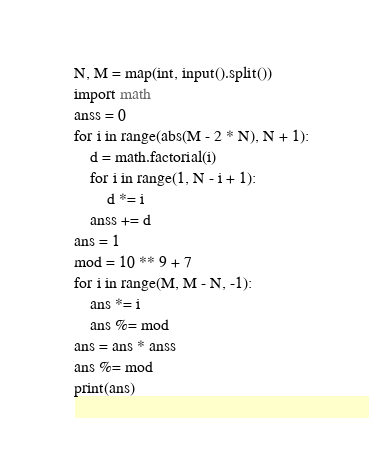Convert code to text. <code><loc_0><loc_0><loc_500><loc_500><_Python_>N, M = map(int, input().split())
import math
anss = 0
for i in range(abs(M - 2 * N), N + 1):
    d = math.factorial(i)
    for i in range(1, N - i + 1):
        d *= i
    anss += d
ans = 1
mod = 10 ** 9 + 7
for i in range(M, M - N, -1):
    ans *= i
    ans %= mod
ans = ans * anss
ans %= mod
print(ans)</code> 